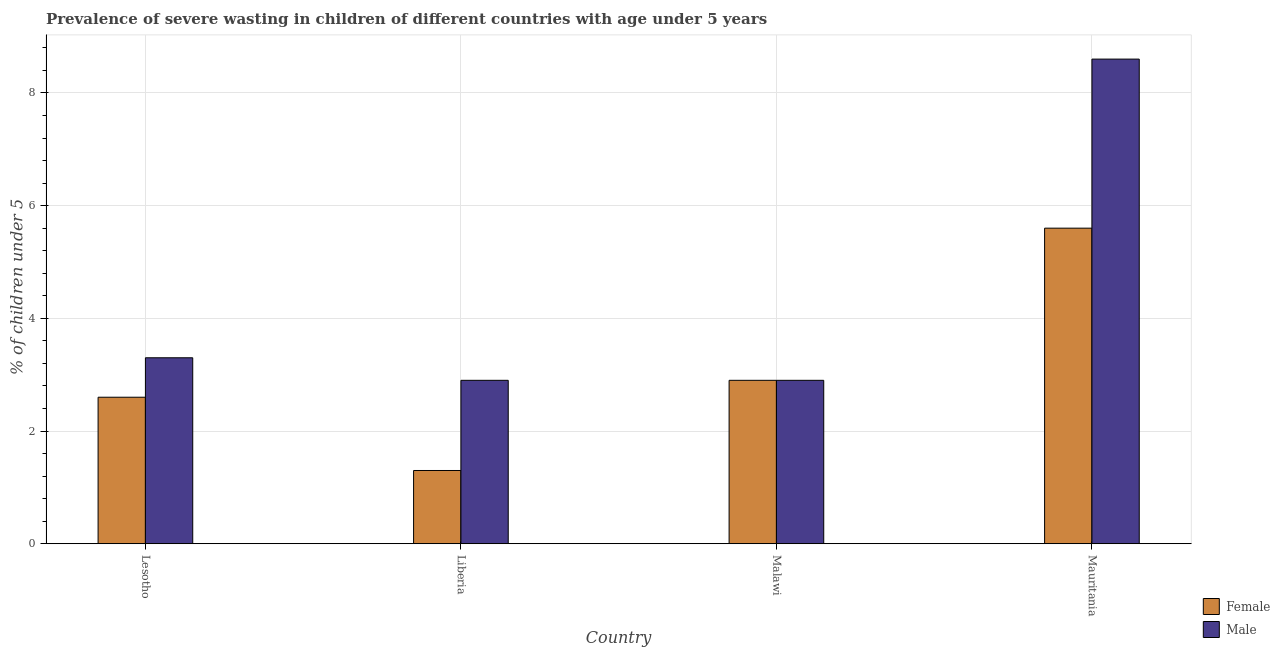How many groups of bars are there?
Provide a short and direct response. 4. Are the number of bars per tick equal to the number of legend labels?
Your response must be concise. Yes. Are the number of bars on each tick of the X-axis equal?
Provide a short and direct response. Yes. How many bars are there on the 2nd tick from the left?
Ensure brevity in your answer.  2. How many bars are there on the 1st tick from the right?
Give a very brief answer. 2. What is the label of the 3rd group of bars from the left?
Offer a very short reply. Malawi. In how many cases, is the number of bars for a given country not equal to the number of legend labels?
Keep it short and to the point. 0. What is the percentage of undernourished male children in Mauritania?
Offer a terse response. 8.6. Across all countries, what is the maximum percentage of undernourished female children?
Your response must be concise. 5.6. Across all countries, what is the minimum percentage of undernourished male children?
Your response must be concise. 2.9. In which country was the percentage of undernourished male children maximum?
Your response must be concise. Mauritania. In which country was the percentage of undernourished female children minimum?
Provide a short and direct response. Liberia. What is the total percentage of undernourished male children in the graph?
Offer a very short reply. 17.7. What is the difference between the percentage of undernourished male children in Liberia and that in Malawi?
Make the answer very short. 0. What is the difference between the percentage of undernourished female children in Lesotho and the percentage of undernourished male children in Malawi?
Your response must be concise. -0.3. What is the average percentage of undernourished female children per country?
Give a very brief answer. 3.1. What is the difference between the percentage of undernourished female children and percentage of undernourished male children in Liberia?
Offer a terse response. -1.6. What is the ratio of the percentage of undernourished female children in Liberia to that in Malawi?
Your answer should be compact. 0.45. Is the difference between the percentage of undernourished male children in Liberia and Malawi greater than the difference between the percentage of undernourished female children in Liberia and Malawi?
Offer a terse response. Yes. What is the difference between the highest and the second highest percentage of undernourished male children?
Ensure brevity in your answer.  5.3. What is the difference between the highest and the lowest percentage of undernourished male children?
Your response must be concise. 5.7. In how many countries, is the percentage of undernourished female children greater than the average percentage of undernourished female children taken over all countries?
Ensure brevity in your answer.  1. What does the 1st bar from the left in Mauritania represents?
Provide a succinct answer. Female. Where does the legend appear in the graph?
Your answer should be very brief. Bottom right. How are the legend labels stacked?
Keep it short and to the point. Vertical. What is the title of the graph?
Make the answer very short. Prevalence of severe wasting in children of different countries with age under 5 years. What is the label or title of the Y-axis?
Provide a short and direct response.  % of children under 5. What is the  % of children under 5 of Female in Lesotho?
Your answer should be very brief. 2.6. What is the  % of children under 5 of Male in Lesotho?
Your answer should be compact. 3.3. What is the  % of children under 5 of Female in Liberia?
Ensure brevity in your answer.  1.3. What is the  % of children under 5 of Male in Liberia?
Make the answer very short. 2.9. What is the  % of children under 5 in Female in Malawi?
Keep it short and to the point. 2.9. What is the  % of children under 5 in Male in Malawi?
Give a very brief answer. 2.9. What is the  % of children under 5 of Female in Mauritania?
Offer a terse response. 5.6. What is the  % of children under 5 in Male in Mauritania?
Give a very brief answer. 8.6. Across all countries, what is the maximum  % of children under 5 in Female?
Make the answer very short. 5.6. Across all countries, what is the maximum  % of children under 5 in Male?
Offer a terse response. 8.6. Across all countries, what is the minimum  % of children under 5 in Female?
Keep it short and to the point. 1.3. Across all countries, what is the minimum  % of children under 5 of Male?
Offer a very short reply. 2.9. What is the total  % of children under 5 in Male in the graph?
Your response must be concise. 17.7. What is the difference between the  % of children under 5 in Female in Lesotho and that in Liberia?
Keep it short and to the point. 1.3. What is the difference between the  % of children under 5 in Male in Lesotho and that in Liberia?
Your answer should be very brief. 0.4. What is the difference between the  % of children under 5 of Female in Lesotho and that in Mauritania?
Your answer should be very brief. -3. What is the difference between the  % of children under 5 of Female in Liberia and that in Malawi?
Offer a very short reply. -1.6. What is the difference between the  % of children under 5 in Male in Liberia and that in Mauritania?
Ensure brevity in your answer.  -5.7. What is the difference between the  % of children under 5 of Male in Malawi and that in Mauritania?
Keep it short and to the point. -5.7. What is the difference between the  % of children under 5 of Female in Lesotho and the  % of children under 5 of Male in Liberia?
Provide a short and direct response. -0.3. What is the difference between the  % of children under 5 of Female in Liberia and the  % of children under 5 of Male in Malawi?
Provide a succinct answer. -1.6. What is the difference between the  % of children under 5 of Female in Liberia and the  % of children under 5 of Male in Mauritania?
Provide a succinct answer. -7.3. What is the average  % of children under 5 in Female per country?
Ensure brevity in your answer.  3.1. What is the average  % of children under 5 in Male per country?
Your answer should be very brief. 4.42. What is the difference between the  % of children under 5 in Female and  % of children under 5 in Male in Malawi?
Provide a short and direct response. 0. What is the ratio of the  % of children under 5 in Male in Lesotho to that in Liberia?
Offer a very short reply. 1.14. What is the ratio of the  % of children under 5 in Female in Lesotho to that in Malawi?
Your answer should be compact. 0.9. What is the ratio of the  % of children under 5 of Male in Lesotho to that in Malawi?
Offer a very short reply. 1.14. What is the ratio of the  % of children under 5 in Female in Lesotho to that in Mauritania?
Your answer should be compact. 0.46. What is the ratio of the  % of children under 5 of Male in Lesotho to that in Mauritania?
Offer a very short reply. 0.38. What is the ratio of the  % of children under 5 in Female in Liberia to that in Malawi?
Offer a terse response. 0.45. What is the ratio of the  % of children under 5 of Female in Liberia to that in Mauritania?
Your response must be concise. 0.23. What is the ratio of the  % of children under 5 in Male in Liberia to that in Mauritania?
Your answer should be very brief. 0.34. What is the ratio of the  % of children under 5 in Female in Malawi to that in Mauritania?
Give a very brief answer. 0.52. What is the ratio of the  % of children under 5 in Male in Malawi to that in Mauritania?
Provide a succinct answer. 0.34. What is the difference between the highest and the second highest  % of children under 5 of Female?
Your answer should be compact. 2.7. What is the difference between the highest and the second highest  % of children under 5 in Male?
Ensure brevity in your answer.  5.3. What is the difference between the highest and the lowest  % of children under 5 in Male?
Offer a very short reply. 5.7. 